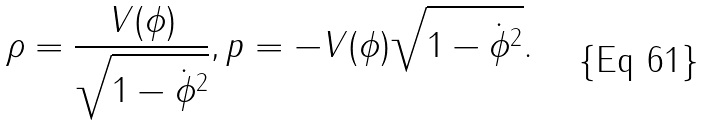<formula> <loc_0><loc_0><loc_500><loc_500>\rho = \frac { V ( \phi ) } { \sqrt { 1 - \dot { \phi } ^ { 2 } } } , p = - V ( \phi ) \sqrt { 1 - \dot { \phi } ^ { 2 } } .</formula> 